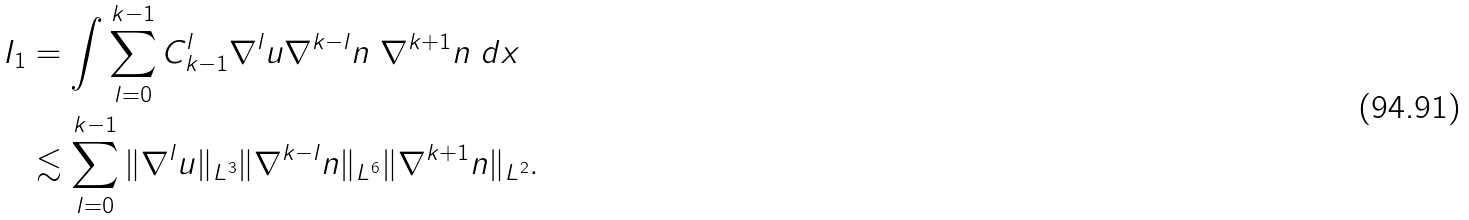Convert formula to latex. <formula><loc_0><loc_0><loc_500><loc_500>I _ { 1 } & = \int \sum _ { l = 0 } ^ { k - 1 } C _ { k - 1 } ^ { l } \nabla ^ { l } u \nabla ^ { k - l } n \ \nabla ^ { k + 1 } n \ d x \\ & \lesssim \sum _ { l = 0 } ^ { k - 1 } \| \nabla ^ { l } u \| _ { L ^ { 3 } } \| \nabla ^ { k - l } n \| _ { L ^ { 6 } } \| \nabla ^ { k + 1 } n \| _ { L ^ { 2 } } .</formula> 